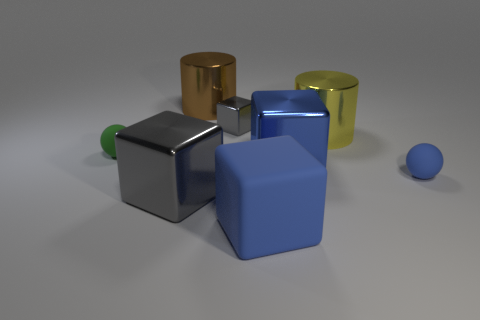Can you tell me the colors of the objects in the image? Certainly! In the image, there are objects in gray, blue, gold, and green colors. 